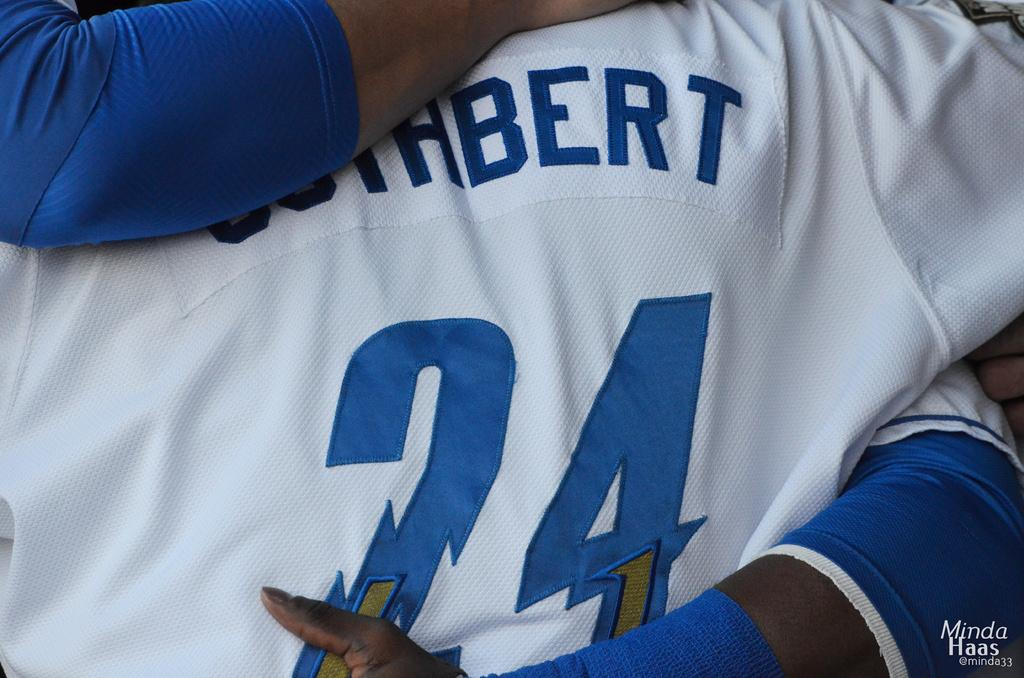<image>
Render a clear and concise summary of the photo. "24" is on a white and blue jersey. 